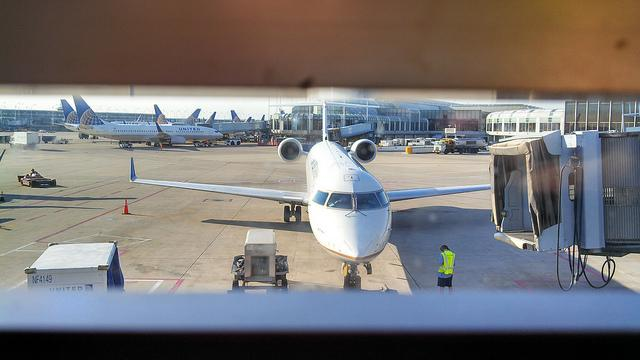What is the large vehicle here?

Choices:
A) helicopter
B) airplane
C) tank
D) submarine airplane 